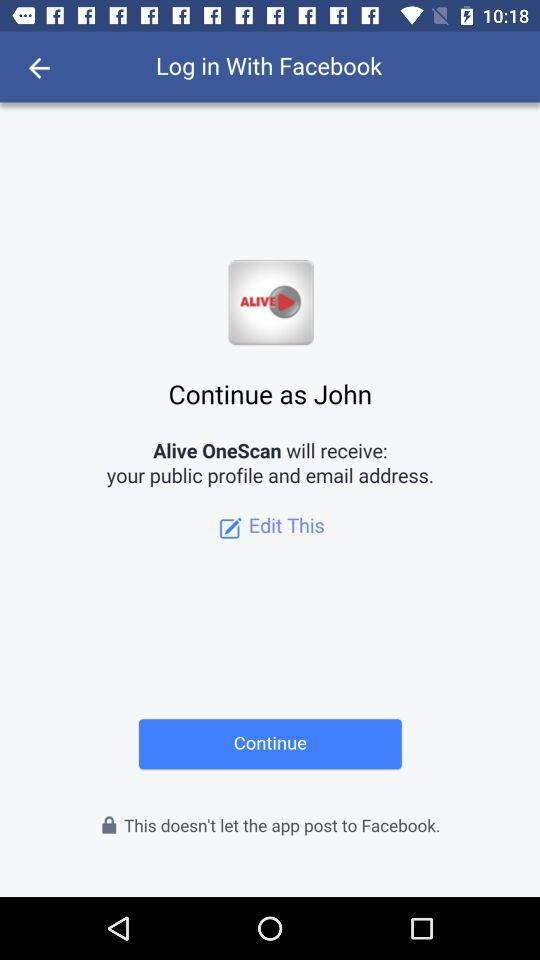Through what application can we log in? You can log in through "Facebook". 